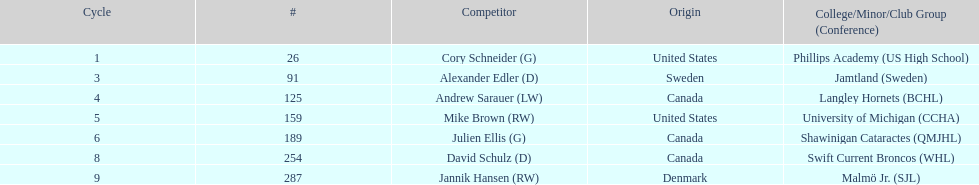How many canadian players are listed? 3. 